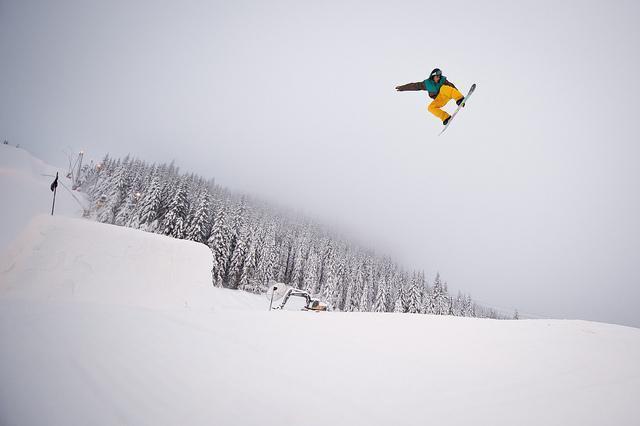How many dogs are laying down?
Give a very brief answer. 0. 